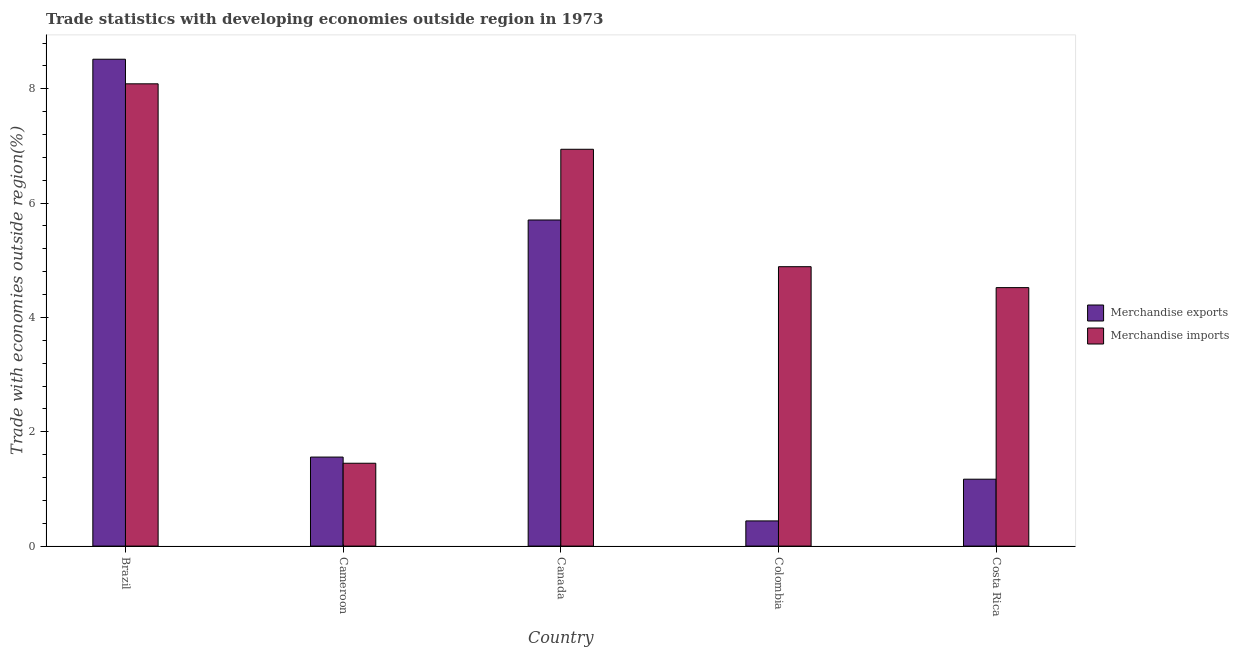How many different coloured bars are there?
Your answer should be very brief. 2. Are the number of bars on each tick of the X-axis equal?
Keep it short and to the point. Yes. What is the merchandise exports in Brazil?
Give a very brief answer. 8.52. Across all countries, what is the maximum merchandise exports?
Your response must be concise. 8.52. Across all countries, what is the minimum merchandise exports?
Your response must be concise. 0.44. What is the total merchandise exports in the graph?
Ensure brevity in your answer.  17.39. What is the difference between the merchandise imports in Cameroon and that in Colombia?
Your answer should be compact. -3.44. What is the difference between the merchandise exports in Costa Rica and the merchandise imports in Colombia?
Your response must be concise. -3.72. What is the average merchandise imports per country?
Ensure brevity in your answer.  5.18. What is the difference between the merchandise imports and merchandise exports in Colombia?
Your answer should be compact. 4.45. In how many countries, is the merchandise imports greater than 6 %?
Offer a very short reply. 2. What is the ratio of the merchandise imports in Cameroon to that in Costa Rica?
Give a very brief answer. 0.32. What is the difference between the highest and the second highest merchandise imports?
Make the answer very short. 1.15. What is the difference between the highest and the lowest merchandise imports?
Ensure brevity in your answer.  6.64. How many bars are there?
Make the answer very short. 10. How many countries are there in the graph?
Give a very brief answer. 5. Does the graph contain any zero values?
Make the answer very short. No. How many legend labels are there?
Offer a terse response. 2. What is the title of the graph?
Offer a very short reply. Trade statistics with developing economies outside region in 1973. What is the label or title of the X-axis?
Keep it short and to the point. Country. What is the label or title of the Y-axis?
Offer a very short reply. Trade with economies outside region(%). What is the Trade with economies outside region(%) in Merchandise exports in Brazil?
Keep it short and to the point. 8.52. What is the Trade with economies outside region(%) in Merchandise imports in Brazil?
Give a very brief answer. 8.09. What is the Trade with economies outside region(%) in Merchandise exports in Cameroon?
Offer a terse response. 1.56. What is the Trade with economies outside region(%) in Merchandise imports in Cameroon?
Offer a very short reply. 1.45. What is the Trade with economies outside region(%) of Merchandise exports in Canada?
Give a very brief answer. 5.7. What is the Trade with economies outside region(%) of Merchandise imports in Canada?
Keep it short and to the point. 6.94. What is the Trade with economies outside region(%) in Merchandise exports in Colombia?
Keep it short and to the point. 0.44. What is the Trade with economies outside region(%) in Merchandise imports in Colombia?
Ensure brevity in your answer.  4.89. What is the Trade with economies outside region(%) in Merchandise exports in Costa Rica?
Offer a terse response. 1.17. What is the Trade with economies outside region(%) in Merchandise imports in Costa Rica?
Provide a short and direct response. 4.52. Across all countries, what is the maximum Trade with economies outside region(%) in Merchandise exports?
Make the answer very short. 8.52. Across all countries, what is the maximum Trade with economies outside region(%) of Merchandise imports?
Keep it short and to the point. 8.09. Across all countries, what is the minimum Trade with economies outside region(%) in Merchandise exports?
Your response must be concise. 0.44. Across all countries, what is the minimum Trade with economies outside region(%) in Merchandise imports?
Your answer should be compact. 1.45. What is the total Trade with economies outside region(%) in Merchandise exports in the graph?
Your answer should be compact. 17.39. What is the total Trade with economies outside region(%) in Merchandise imports in the graph?
Your answer should be very brief. 25.89. What is the difference between the Trade with economies outside region(%) of Merchandise exports in Brazil and that in Cameroon?
Provide a succinct answer. 6.96. What is the difference between the Trade with economies outside region(%) in Merchandise imports in Brazil and that in Cameroon?
Make the answer very short. 6.64. What is the difference between the Trade with economies outside region(%) of Merchandise exports in Brazil and that in Canada?
Your answer should be very brief. 2.81. What is the difference between the Trade with economies outside region(%) of Merchandise imports in Brazil and that in Canada?
Keep it short and to the point. 1.15. What is the difference between the Trade with economies outside region(%) in Merchandise exports in Brazil and that in Colombia?
Offer a very short reply. 8.08. What is the difference between the Trade with economies outside region(%) of Merchandise imports in Brazil and that in Colombia?
Keep it short and to the point. 3.2. What is the difference between the Trade with economies outside region(%) of Merchandise exports in Brazil and that in Costa Rica?
Offer a terse response. 7.35. What is the difference between the Trade with economies outside region(%) of Merchandise imports in Brazil and that in Costa Rica?
Make the answer very short. 3.56. What is the difference between the Trade with economies outside region(%) in Merchandise exports in Cameroon and that in Canada?
Give a very brief answer. -4.15. What is the difference between the Trade with economies outside region(%) in Merchandise imports in Cameroon and that in Canada?
Your response must be concise. -5.49. What is the difference between the Trade with economies outside region(%) in Merchandise exports in Cameroon and that in Colombia?
Your answer should be compact. 1.12. What is the difference between the Trade with economies outside region(%) of Merchandise imports in Cameroon and that in Colombia?
Offer a very short reply. -3.44. What is the difference between the Trade with economies outside region(%) in Merchandise exports in Cameroon and that in Costa Rica?
Your response must be concise. 0.39. What is the difference between the Trade with economies outside region(%) of Merchandise imports in Cameroon and that in Costa Rica?
Offer a very short reply. -3.07. What is the difference between the Trade with economies outside region(%) of Merchandise exports in Canada and that in Colombia?
Offer a very short reply. 5.26. What is the difference between the Trade with economies outside region(%) in Merchandise imports in Canada and that in Colombia?
Provide a short and direct response. 2.05. What is the difference between the Trade with economies outside region(%) of Merchandise exports in Canada and that in Costa Rica?
Your response must be concise. 4.53. What is the difference between the Trade with economies outside region(%) in Merchandise imports in Canada and that in Costa Rica?
Offer a terse response. 2.42. What is the difference between the Trade with economies outside region(%) of Merchandise exports in Colombia and that in Costa Rica?
Ensure brevity in your answer.  -0.73. What is the difference between the Trade with economies outside region(%) in Merchandise imports in Colombia and that in Costa Rica?
Provide a succinct answer. 0.37. What is the difference between the Trade with economies outside region(%) in Merchandise exports in Brazil and the Trade with economies outside region(%) in Merchandise imports in Cameroon?
Provide a short and direct response. 7.07. What is the difference between the Trade with economies outside region(%) in Merchandise exports in Brazil and the Trade with economies outside region(%) in Merchandise imports in Canada?
Make the answer very short. 1.58. What is the difference between the Trade with economies outside region(%) in Merchandise exports in Brazil and the Trade with economies outside region(%) in Merchandise imports in Colombia?
Offer a very short reply. 3.63. What is the difference between the Trade with economies outside region(%) in Merchandise exports in Brazil and the Trade with economies outside region(%) in Merchandise imports in Costa Rica?
Give a very brief answer. 4. What is the difference between the Trade with economies outside region(%) of Merchandise exports in Cameroon and the Trade with economies outside region(%) of Merchandise imports in Canada?
Give a very brief answer. -5.38. What is the difference between the Trade with economies outside region(%) of Merchandise exports in Cameroon and the Trade with economies outside region(%) of Merchandise imports in Colombia?
Provide a short and direct response. -3.33. What is the difference between the Trade with economies outside region(%) of Merchandise exports in Cameroon and the Trade with economies outside region(%) of Merchandise imports in Costa Rica?
Keep it short and to the point. -2.96. What is the difference between the Trade with economies outside region(%) in Merchandise exports in Canada and the Trade with economies outside region(%) in Merchandise imports in Colombia?
Keep it short and to the point. 0.82. What is the difference between the Trade with economies outside region(%) of Merchandise exports in Canada and the Trade with economies outside region(%) of Merchandise imports in Costa Rica?
Provide a succinct answer. 1.18. What is the difference between the Trade with economies outside region(%) of Merchandise exports in Colombia and the Trade with economies outside region(%) of Merchandise imports in Costa Rica?
Offer a terse response. -4.08. What is the average Trade with economies outside region(%) of Merchandise exports per country?
Give a very brief answer. 3.48. What is the average Trade with economies outside region(%) in Merchandise imports per country?
Provide a succinct answer. 5.18. What is the difference between the Trade with economies outside region(%) in Merchandise exports and Trade with economies outside region(%) in Merchandise imports in Brazil?
Provide a short and direct response. 0.43. What is the difference between the Trade with economies outside region(%) in Merchandise exports and Trade with economies outside region(%) in Merchandise imports in Cameroon?
Ensure brevity in your answer.  0.11. What is the difference between the Trade with economies outside region(%) of Merchandise exports and Trade with economies outside region(%) of Merchandise imports in Canada?
Ensure brevity in your answer.  -1.24. What is the difference between the Trade with economies outside region(%) in Merchandise exports and Trade with economies outside region(%) in Merchandise imports in Colombia?
Give a very brief answer. -4.45. What is the difference between the Trade with economies outside region(%) in Merchandise exports and Trade with economies outside region(%) in Merchandise imports in Costa Rica?
Provide a succinct answer. -3.35. What is the ratio of the Trade with economies outside region(%) in Merchandise exports in Brazil to that in Cameroon?
Your answer should be compact. 5.47. What is the ratio of the Trade with economies outside region(%) of Merchandise imports in Brazil to that in Cameroon?
Provide a short and direct response. 5.58. What is the ratio of the Trade with economies outside region(%) in Merchandise exports in Brazil to that in Canada?
Make the answer very short. 1.49. What is the ratio of the Trade with economies outside region(%) in Merchandise imports in Brazil to that in Canada?
Your response must be concise. 1.17. What is the ratio of the Trade with economies outside region(%) of Merchandise exports in Brazil to that in Colombia?
Give a very brief answer. 19.33. What is the ratio of the Trade with economies outside region(%) in Merchandise imports in Brazil to that in Colombia?
Provide a short and direct response. 1.65. What is the ratio of the Trade with economies outside region(%) of Merchandise exports in Brazil to that in Costa Rica?
Keep it short and to the point. 7.28. What is the ratio of the Trade with economies outside region(%) of Merchandise imports in Brazil to that in Costa Rica?
Ensure brevity in your answer.  1.79. What is the ratio of the Trade with economies outside region(%) of Merchandise exports in Cameroon to that in Canada?
Keep it short and to the point. 0.27. What is the ratio of the Trade with economies outside region(%) of Merchandise imports in Cameroon to that in Canada?
Offer a terse response. 0.21. What is the ratio of the Trade with economies outside region(%) of Merchandise exports in Cameroon to that in Colombia?
Offer a terse response. 3.53. What is the ratio of the Trade with economies outside region(%) of Merchandise imports in Cameroon to that in Colombia?
Provide a succinct answer. 0.3. What is the ratio of the Trade with economies outside region(%) of Merchandise exports in Cameroon to that in Costa Rica?
Make the answer very short. 1.33. What is the ratio of the Trade with economies outside region(%) in Merchandise imports in Cameroon to that in Costa Rica?
Offer a terse response. 0.32. What is the ratio of the Trade with economies outside region(%) in Merchandise exports in Canada to that in Colombia?
Ensure brevity in your answer.  12.95. What is the ratio of the Trade with economies outside region(%) in Merchandise imports in Canada to that in Colombia?
Your response must be concise. 1.42. What is the ratio of the Trade with economies outside region(%) of Merchandise exports in Canada to that in Costa Rica?
Keep it short and to the point. 4.87. What is the ratio of the Trade with economies outside region(%) in Merchandise imports in Canada to that in Costa Rica?
Ensure brevity in your answer.  1.54. What is the ratio of the Trade with economies outside region(%) of Merchandise exports in Colombia to that in Costa Rica?
Your response must be concise. 0.38. What is the ratio of the Trade with economies outside region(%) of Merchandise imports in Colombia to that in Costa Rica?
Offer a terse response. 1.08. What is the difference between the highest and the second highest Trade with economies outside region(%) in Merchandise exports?
Provide a short and direct response. 2.81. What is the difference between the highest and the second highest Trade with economies outside region(%) of Merchandise imports?
Give a very brief answer. 1.15. What is the difference between the highest and the lowest Trade with economies outside region(%) in Merchandise exports?
Keep it short and to the point. 8.08. What is the difference between the highest and the lowest Trade with economies outside region(%) in Merchandise imports?
Give a very brief answer. 6.64. 